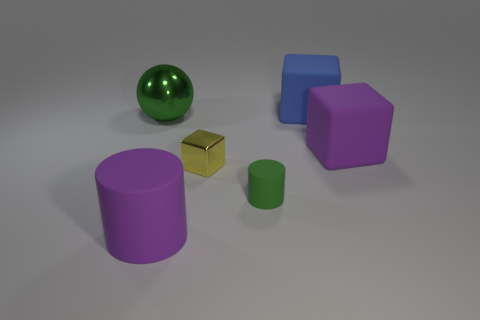There is a big object that is both behind the tiny yellow block and on the left side of the big blue cube; what color is it?
Offer a terse response. Green. What is the shape of the green object that is the same material as the blue block?
Offer a very short reply. Cylinder. What number of big matte objects are in front of the large green thing and to the right of the tiny green cylinder?
Your answer should be compact. 1. There is a purple matte cylinder; are there any big blocks to the right of it?
Provide a succinct answer. Yes. Does the green object that is to the right of the large purple cylinder have the same shape as the large purple rubber object that is in front of the tiny green cylinder?
Your response must be concise. Yes. How many things are big purple rubber cylinders or purple things to the left of the large blue rubber cube?
Your answer should be compact. 1. What number of other things are the same shape as the small rubber object?
Your response must be concise. 1. Is the material of the tiny thing on the left side of the small green object the same as the purple cylinder?
Provide a succinct answer. No. What number of things are either small blue matte blocks or blue matte blocks?
Ensure brevity in your answer.  1. There is a purple rubber object that is the same shape as the blue rubber object; what is its size?
Your response must be concise. Large. 